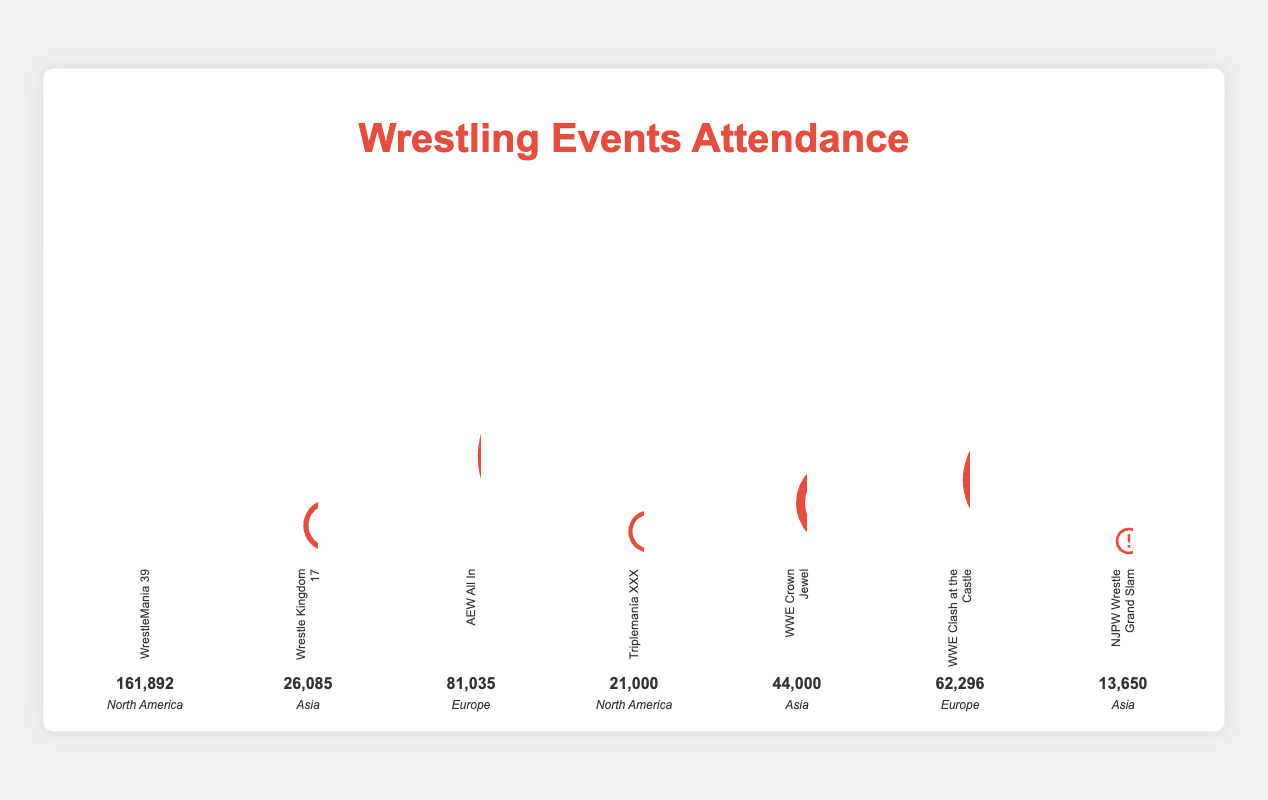What is the title of the figure? The title is usually located at the top of the figure and describes the content visually represented in the figure. Here, it is written as a large heading.
Answer: Wrestling Events Attendance How many events are included in the figure? By counting the number of distinct bars or sections representing different events in the chart, we can tally up the total number.
Answer: 7 Which event had the highest attendance, and what was the attendance figure? By observing the height of the bars or sections and identifying the tallest one, we find that "WrestleMania 39" is the tallest. The attendance figure is displayed under its bar.
Answer: WrestleMania 39, 161,892 How does the attendance of Wrestle Kingdom 17 compare to WWE Crown Jewel? By comparing the heights of the respective bars for "Wrestle Kingdom 17" and "WWE Crown Jewel", we notice that WWE Crown Jewel is taller. Their stated attendance figures confirm this.
Answer: 26,085 vs. 44,000 Which continent hosted the most-attended event? By identifying the event with the highest attendance (WrestleMania 39) and then looking at its labeled continent, we determine the continent.
Answer: North America What is the combined attendance of all events held in Europe? Summing the attendance figures for "AEW All In" and "WWE Clash at the Castle", the two events held in Europe, we calculate the combined attendance.
Answer: 81,035 + 62,296 = 143,331 Which event has the lowest attendance, and what was the figure? By finding the shortest bar in the chart and noting its label and attendance figure, we identify "NJPW Wrestle Grand Slam" as the event with the lowest attendance.
Answer: NJPW Wrestle Grand Slam, 13,650 How does the total attendance for events in Asia compare to the attendance for WrestleMania 39 alone? Adding the attendance figures for the three Asian events and comparing this sum to the attendance figure for "WrestleMania 39", we perform a comparison.
Answer: 26,085 + 44,000 + 13,650 = 83,735 vs. 161,892 What is the average attendance of all North American events? Adding the attendance figures for the two North American events and dividing by the number of these events, we calculate the average attendance.
Answer: (161,892 + 21,000) / 2 = 91,446 Which event had an attendance that fell between 40,000 and 50,000? By checking the attendance figures for each event to see which one falls within this range, we determine "WWE Crown Jewel" fits the criteria.
Answer: WWE Crown Jewel, 44,000 